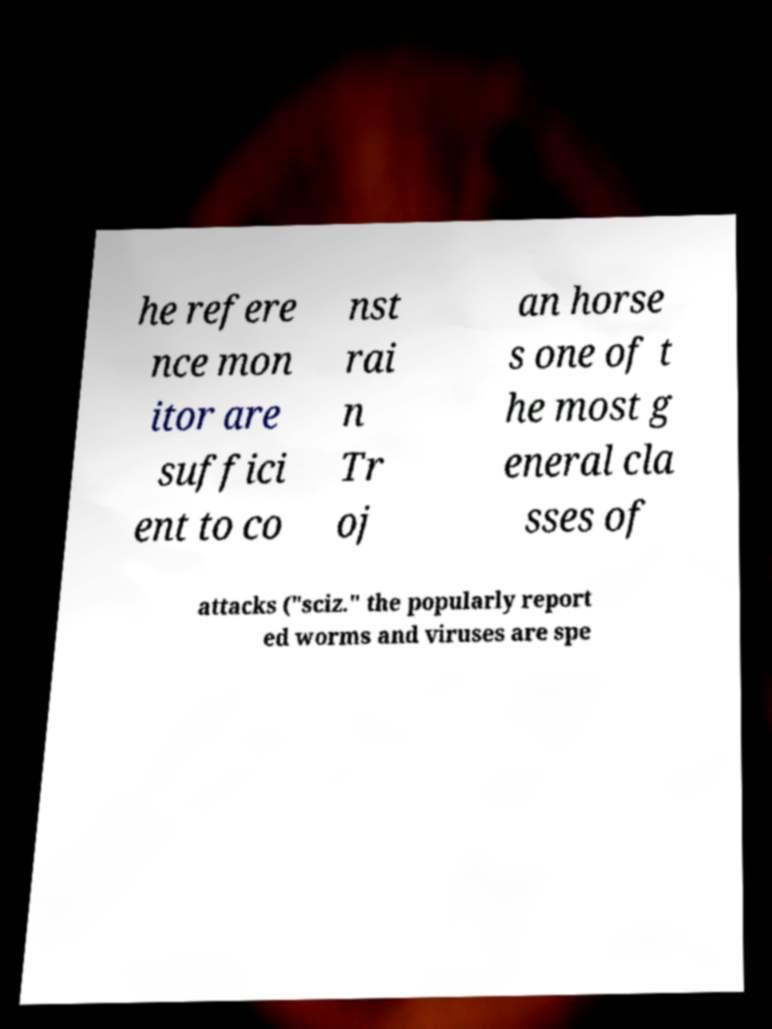For documentation purposes, I need the text within this image transcribed. Could you provide that? he refere nce mon itor are suffici ent to co nst rai n Tr oj an horse s one of t he most g eneral cla sses of attacks ("sciz." the popularly report ed worms and viruses are spe 